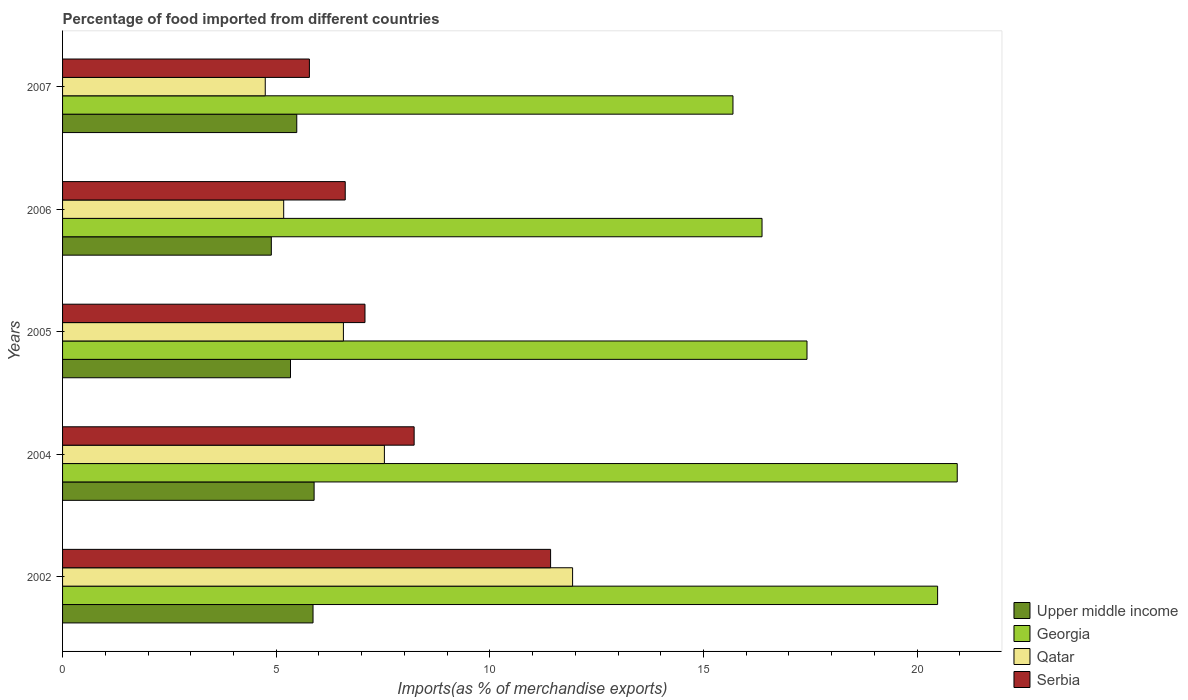Are the number of bars per tick equal to the number of legend labels?
Give a very brief answer. Yes. Are the number of bars on each tick of the Y-axis equal?
Make the answer very short. Yes. How many bars are there on the 2nd tick from the top?
Provide a short and direct response. 4. How many bars are there on the 3rd tick from the bottom?
Provide a succinct answer. 4. What is the label of the 5th group of bars from the top?
Keep it short and to the point. 2002. What is the percentage of imports to different countries in Qatar in 2007?
Offer a very short reply. 4.74. Across all years, what is the maximum percentage of imports to different countries in Qatar?
Keep it short and to the point. 11.94. Across all years, what is the minimum percentage of imports to different countries in Serbia?
Ensure brevity in your answer.  5.78. In which year was the percentage of imports to different countries in Qatar maximum?
Keep it short and to the point. 2002. In which year was the percentage of imports to different countries in Upper middle income minimum?
Make the answer very short. 2006. What is the total percentage of imports to different countries in Upper middle income in the graph?
Ensure brevity in your answer.  27.45. What is the difference between the percentage of imports to different countries in Upper middle income in 2006 and that in 2007?
Give a very brief answer. -0.6. What is the difference between the percentage of imports to different countries in Serbia in 2005 and the percentage of imports to different countries in Qatar in 2002?
Your answer should be compact. -4.86. What is the average percentage of imports to different countries in Qatar per year?
Your response must be concise. 7.19. In the year 2004, what is the difference between the percentage of imports to different countries in Upper middle income and percentage of imports to different countries in Georgia?
Make the answer very short. -15.05. What is the ratio of the percentage of imports to different countries in Serbia in 2004 to that in 2007?
Keep it short and to the point. 1.42. What is the difference between the highest and the second highest percentage of imports to different countries in Upper middle income?
Ensure brevity in your answer.  0.03. What is the difference between the highest and the lowest percentage of imports to different countries in Georgia?
Your response must be concise. 5.25. In how many years, is the percentage of imports to different countries in Georgia greater than the average percentage of imports to different countries in Georgia taken over all years?
Keep it short and to the point. 2. Is the sum of the percentage of imports to different countries in Upper middle income in 2002 and 2005 greater than the maximum percentage of imports to different countries in Qatar across all years?
Offer a very short reply. No. Is it the case that in every year, the sum of the percentage of imports to different countries in Serbia and percentage of imports to different countries in Upper middle income is greater than the sum of percentage of imports to different countries in Georgia and percentage of imports to different countries in Qatar?
Your answer should be compact. No. What does the 3rd bar from the top in 2006 represents?
Your response must be concise. Georgia. What does the 1st bar from the bottom in 2006 represents?
Provide a short and direct response. Upper middle income. Is it the case that in every year, the sum of the percentage of imports to different countries in Serbia and percentage of imports to different countries in Georgia is greater than the percentage of imports to different countries in Qatar?
Offer a very short reply. Yes. Are all the bars in the graph horizontal?
Provide a short and direct response. Yes. How many years are there in the graph?
Your answer should be compact. 5. What is the difference between two consecutive major ticks on the X-axis?
Provide a succinct answer. 5. Does the graph contain grids?
Make the answer very short. No. Where does the legend appear in the graph?
Make the answer very short. Bottom right. How are the legend labels stacked?
Keep it short and to the point. Vertical. What is the title of the graph?
Give a very brief answer. Percentage of food imported from different countries. What is the label or title of the X-axis?
Your answer should be very brief. Imports(as % of merchandise exports). What is the label or title of the Y-axis?
Ensure brevity in your answer.  Years. What is the Imports(as % of merchandise exports) of Upper middle income in 2002?
Ensure brevity in your answer.  5.86. What is the Imports(as % of merchandise exports) of Georgia in 2002?
Provide a succinct answer. 20.48. What is the Imports(as % of merchandise exports) in Qatar in 2002?
Give a very brief answer. 11.94. What is the Imports(as % of merchandise exports) of Serbia in 2002?
Your answer should be very brief. 11.42. What is the Imports(as % of merchandise exports) in Upper middle income in 2004?
Ensure brevity in your answer.  5.89. What is the Imports(as % of merchandise exports) of Georgia in 2004?
Offer a terse response. 20.94. What is the Imports(as % of merchandise exports) in Qatar in 2004?
Give a very brief answer. 7.53. What is the Imports(as % of merchandise exports) in Serbia in 2004?
Ensure brevity in your answer.  8.23. What is the Imports(as % of merchandise exports) of Upper middle income in 2005?
Give a very brief answer. 5.33. What is the Imports(as % of merchandise exports) of Georgia in 2005?
Provide a succinct answer. 17.42. What is the Imports(as % of merchandise exports) of Qatar in 2005?
Offer a terse response. 6.57. What is the Imports(as % of merchandise exports) of Serbia in 2005?
Offer a very short reply. 7.08. What is the Imports(as % of merchandise exports) of Upper middle income in 2006?
Your response must be concise. 4.89. What is the Imports(as % of merchandise exports) in Georgia in 2006?
Give a very brief answer. 16.37. What is the Imports(as % of merchandise exports) in Qatar in 2006?
Make the answer very short. 5.18. What is the Imports(as % of merchandise exports) in Serbia in 2006?
Make the answer very short. 6.62. What is the Imports(as % of merchandise exports) in Upper middle income in 2007?
Your response must be concise. 5.48. What is the Imports(as % of merchandise exports) of Georgia in 2007?
Keep it short and to the point. 15.69. What is the Imports(as % of merchandise exports) of Qatar in 2007?
Provide a short and direct response. 4.74. What is the Imports(as % of merchandise exports) in Serbia in 2007?
Give a very brief answer. 5.78. Across all years, what is the maximum Imports(as % of merchandise exports) in Upper middle income?
Ensure brevity in your answer.  5.89. Across all years, what is the maximum Imports(as % of merchandise exports) in Georgia?
Your answer should be very brief. 20.94. Across all years, what is the maximum Imports(as % of merchandise exports) in Qatar?
Give a very brief answer. 11.94. Across all years, what is the maximum Imports(as % of merchandise exports) of Serbia?
Your answer should be very brief. 11.42. Across all years, what is the minimum Imports(as % of merchandise exports) of Upper middle income?
Provide a succinct answer. 4.89. Across all years, what is the minimum Imports(as % of merchandise exports) in Georgia?
Your answer should be very brief. 15.69. Across all years, what is the minimum Imports(as % of merchandise exports) in Qatar?
Give a very brief answer. 4.74. Across all years, what is the minimum Imports(as % of merchandise exports) of Serbia?
Provide a succinct answer. 5.78. What is the total Imports(as % of merchandise exports) of Upper middle income in the graph?
Offer a very short reply. 27.45. What is the total Imports(as % of merchandise exports) of Georgia in the graph?
Your answer should be compact. 90.9. What is the total Imports(as % of merchandise exports) of Qatar in the graph?
Offer a terse response. 35.96. What is the total Imports(as % of merchandise exports) of Serbia in the graph?
Offer a terse response. 39.12. What is the difference between the Imports(as % of merchandise exports) of Upper middle income in 2002 and that in 2004?
Make the answer very short. -0.03. What is the difference between the Imports(as % of merchandise exports) of Georgia in 2002 and that in 2004?
Provide a succinct answer. -0.46. What is the difference between the Imports(as % of merchandise exports) in Qatar in 2002 and that in 2004?
Your response must be concise. 4.4. What is the difference between the Imports(as % of merchandise exports) of Serbia in 2002 and that in 2004?
Your answer should be very brief. 3.19. What is the difference between the Imports(as % of merchandise exports) in Upper middle income in 2002 and that in 2005?
Keep it short and to the point. 0.53. What is the difference between the Imports(as % of merchandise exports) of Georgia in 2002 and that in 2005?
Provide a short and direct response. 3.06. What is the difference between the Imports(as % of merchandise exports) of Qatar in 2002 and that in 2005?
Provide a short and direct response. 5.36. What is the difference between the Imports(as % of merchandise exports) of Serbia in 2002 and that in 2005?
Your answer should be very brief. 4.34. What is the difference between the Imports(as % of merchandise exports) in Upper middle income in 2002 and that in 2006?
Your answer should be very brief. 0.98. What is the difference between the Imports(as % of merchandise exports) of Georgia in 2002 and that in 2006?
Provide a succinct answer. 4.11. What is the difference between the Imports(as % of merchandise exports) in Qatar in 2002 and that in 2006?
Provide a succinct answer. 6.76. What is the difference between the Imports(as % of merchandise exports) in Serbia in 2002 and that in 2006?
Your response must be concise. 4.81. What is the difference between the Imports(as % of merchandise exports) in Upper middle income in 2002 and that in 2007?
Offer a terse response. 0.38. What is the difference between the Imports(as % of merchandise exports) in Georgia in 2002 and that in 2007?
Your response must be concise. 4.79. What is the difference between the Imports(as % of merchandise exports) of Qatar in 2002 and that in 2007?
Give a very brief answer. 7.19. What is the difference between the Imports(as % of merchandise exports) of Serbia in 2002 and that in 2007?
Give a very brief answer. 5.64. What is the difference between the Imports(as % of merchandise exports) of Upper middle income in 2004 and that in 2005?
Your answer should be very brief. 0.55. What is the difference between the Imports(as % of merchandise exports) of Georgia in 2004 and that in 2005?
Your answer should be compact. 3.52. What is the difference between the Imports(as % of merchandise exports) in Qatar in 2004 and that in 2005?
Your answer should be compact. 0.96. What is the difference between the Imports(as % of merchandise exports) of Serbia in 2004 and that in 2005?
Your answer should be compact. 1.15. What is the difference between the Imports(as % of merchandise exports) of Georgia in 2004 and that in 2006?
Ensure brevity in your answer.  4.57. What is the difference between the Imports(as % of merchandise exports) in Qatar in 2004 and that in 2006?
Offer a terse response. 2.36. What is the difference between the Imports(as % of merchandise exports) in Serbia in 2004 and that in 2006?
Your response must be concise. 1.61. What is the difference between the Imports(as % of merchandise exports) in Upper middle income in 2004 and that in 2007?
Offer a very short reply. 0.41. What is the difference between the Imports(as % of merchandise exports) of Georgia in 2004 and that in 2007?
Make the answer very short. 5.25. What is the difference between the Imports(as % of merchandise exports) in Qatar in 2004 and that in 2007?
Your answer should be compact. 2.79. What is the difference between the Imports(as % of merchandise exports) of Serbia in 2004 and that in 2007?
Provide a short and direct response. 2.45. What is the difference between the Imports(as % of merchandise exports) in Upper middle income in 2005 and that in 2006?
Make the answer very short. 0.45. What is the difference between the Imports(as % of merchandise exports) of Georgia in 2005 and that in 2006?
Provide a short and direct response. 1.05. What is the difference between the Imports(as % of merchandise exports) of Qatar in 2005 and that in 2006?
Your answer should be very brief. 1.4. What is the difference between the Imports(as % of merchandise exports) in Serbia in 2005 and that in 2006?
Your response must be concise. 0.46. What is the difference between the Imports(as % of merchandise exports) of Upper middle income in 2005 and that in 2007?
Provide a short and direct response. -0.15. What is the difference between the Imports(as % of merchandise exports) of Georgia in 2005 and that in 2007?
Your answer should be compact. 1.73. What is the difference between the Imports(as % of merchandise exports) in Qatar in 2005 and that in 2007?
Provide a short and direct response. 1.83. What is the difference between the Imports(as % of merchandise exports) of Serbia in 2005 and that in 2007?
Keep it short and to the point. 1.3. What is the difference between the Imports(as % of merchandise exports) of Upper middle income in 2006 and that in 2007?
Provide a succinct answer. -0.6. What is the difference between the Imports(as % of merchandise exports) of Georgia in 2006 and that in 2007?
Provide a short and direct response. 0.68. What is the difference between the Imports(as % of merchandise exports) in Qatar in 2006 and that in 2007?
Provide a succinct answer. 0.43. What is the difference between the Imports(as % of merchandise exports) in Serbia in 2006 and that in 2007?
Keep it short and to the point. 0.84. What is the difference between the Imports(as % of merchandise exports) of Upper middle income in 2002 and the Imports(as % of merchandise exports) of Georgia in 2004?
Your answer should be very brief. -15.08. What is the difference between the Imports(as % of merchandise exports) in Upper middle income in 2002 and the Imports(as % of merchandise exports) in Qatar in 2004?
Your answer should be compact. -1.67. What is the difference between the Imports(as % of merchandise exports) in Upper middle income in 2002 and the Imports(as % of merchandise exports) in Serbia in 2004?
Offer a terse response. -2.37. What is the difference between the Imports(as % of merchandise exports) in Georgia in 2002 and the Imports(as % of merchandise exports) in Qatar in 2004?
Your answer should be very brief. 12.95. What is the difference between the Imports(as % of merchandise exports) in Georgia in 2002 and the Imports(as % of merchandise exports) in Serbia in 2004?
Ensure brevity in your answer.  12.25. What is the difference between the Imports(as % of merchandise exports) in Qatar in 2002 and the Imports(as % of merchandise exports) in Serbia in 2004?
Provide a succinct answer. 3.71. What is the difference between the Imports(as % of merchandise exports) of Upper middle income in 2002 and the Imports(as % of merchandise exports) of Georgia in 2005?
Your answer should be very brief. -11.56. What is the difference between the Imports(as % of merchandise exports) in Upper middle income in 2002 and the Imports(as % of merchandise exports) in Qatar in 2005?
Make the answer very short. -0.71. What is the difference between the Imports(as % of merchandise exports) in Upper middle income in 2002 and the Imports(as % of merchandise exports) in Serbia in 2005?
Your answer should be compact. -1.22. What is the difference between the Imports(as % of merchandise exports) in Georgia in 2002 and the Imports(as % of merchandise exports) in Qatar in 2005?
Make the answer very short. 13.91. What is the difference between the Imports(as % of merchandise exports) in Georgia in 2002 and the Imports(as % of merchandise exports) in Serbia in 2005?
Your response must be concise. 13.4. What is the difference between the Imports(as % of merchandise exports) in Qatar in 2002 and the Imports(as % of merchandise exports) in Serbia in 2005?
Make the answer very short. 4.86. What is the difference between the Imports(as % of merchandise exports) in Upper middle income in 2002 and the Imports(as % of merchandise exports) in Georgia in 2006?
Give a very brief answer. -10.51. What is the difference between the Imports(as % of merchandise exports) of Upper middle income in 2002 and the Imports(as % of merchandise exports) of Qatar in 2006?
Provide a succinct answer. 0.69. What is the difference between the Imports(as % of merchandise exports) of Upper middle income in 2002 and the Imports(as % of merchandise exports) of Serbia in 2006?
Provide a succinct answer. -0.75. What is the difference between the Imports(as % of merchandise exports) in Georgia in 2002 and the Imports(as % of merchandise exports) in Qatar in 2006?
Your answer should be compact. 15.3. What is the difference between the Imports(as % of merchandise exports) in Georgia in 2002 and the Imports(as % of merchandise exports) in Serbia in 2006?
Your answer should be compact. 13.86. What is the difference between the Imports(as % of merchandise exports) in Qatar in 2002 and the Imports(as % of merchandise exports) in Serbia in 2006?
Your answer should be compact. 5.32. What is the difference between the Imports(as % of merchandise exports) of Upper middle income in 2002 and the Imports(as % of merchandise exports) of Georgia in 2007?
Ensure brevity in your answer.  -9.83. What is the difference between the Imports(as % of merchandise exports) of Upper middle income in 2002 and the Imports(as % of merchandise exports) of Qatar in 2007?
Your answer should be compact. 1.12. What is the difference between the Imports(as % of merchandise exports) in Upper middle income in 2002 and the Imports(as % of merchandise exports) in Serbia in 2007?
Make the answer very short. 0.08. What is the difference between the Imports(as % of merchandise exports) in Georgia in 2002 and the Imports(as % of merchandise exports) in Qatar in 2007?
Your response must be concise. 15.74. What is the difference between the Imports(as % of merchandise exports) of Georgia in 2002 and the Imports(as % of merchandise exports) of Serbia in 2007?
Your response must be concise. 14.7. What is the difference between the Imports(as % of merchandise exports) of Qatar in 2002 and the Imports(as % of merchandise exports) of Serbia in 2007?
Make the answer very short. 6.16. What is the difference between the Imports(as % of merchandise exports) in Upper middle income in 2004 and the Imports(as % of merchandise exports) in Georgia in 2005?
Keep it short and to the point. -11.54. What is the difference between the Imports(as % of merchandise exports) in Upper middle income in 2004 and the Imports(as % of merchandise exports) in Qatar in 2005?
Keep it short and to the point. -0.69. What is the difference between the Imports(as % of merchandise exports) in Upper middle income in 2004 and the Imports(as % of merchandise exports) in Serbia in 2005?
Provide a short and direct response. -1.19. What is the difference between the Imports(as % of merchandise exports) of Georgia in 2004 and the Imports(as % of merchandise exports) of Qatar in 2005?
Offer a terse response. 14.37. What is the difference between the Imports(as % of merchandise exports) in Georgia in 2004 and the Imports(as % of merchandise exports) in Serbia in 2005?
Your answer should be very brief. 13.86. What is the difference between the Imports(as % of merchandise exports) of Qatar in 2004 and the Imports(as % of merchandise exports) of Serbia in 2005?
Provide a short and direct response. 0.45. What is the difference between the Imports(as % of merchandise exports) of Upper middle income in 2004 and the Imports(as % of merchandise exports) of Georgia in 2006?
Your answer should be compact. -10.48. What is the difference between the Imports(as % of merchandise exports) in Upper middle income in 2004 and the Imports(as % of merchandise exports) in Qatar in 2006?
Offer a very short reply. 0.71. What is the difference between the Imports(as % of merchandise exports) in Upper middle income in 2004 and the Imports(as % of merchandise exports) in Serbia in 2006?
Provide a succinct answer. -0.73. What is the difference between the Imports(as % of merchandise exports) in Georgia in 2004 and the Imports(as % of merchandise exports) in Qatar in 2006?
Provide a short and direct response. 15.76. What is the difference between the Imports(as % of merchandise exports) of Georgia in 2004 and the Imports(as % of merchandise exports) of Serbia in 2006?
Your answer should be very brief. 14.32. What is the difference between the Imports(as % of merchandise exports) of Upper middle income in 2004 and the Imports(as % of merchandise exports) of Georgia in 2007?
Keep it short and to the point. -9.8. What is the difference between the Imports(as % of merchandise exports) in Upper middle income in 2004 and the Imports(as % of merchandise exports) in Qatar in 2007?
Ensure brevity in your answer.  1.14. What is the difference between the Imports(as % of merchandise exports) in Upper middle income in 2004 and the Imports(as % of merchandise exports) in Serbia in 2007?
Your answer should be compact. 0.11. What is the difference between the Imports(as % of merchandise exports) of Georgia in 2004 and the Imports(as % of merchandise exports) of Qatar in 2007?
Your answer should be compact. 16.2. What is the difference between the Imports(as % of merchandise exports) of Georgia in 2004 and the Imports(as % of merchandise exports) of Serbia in 2007?
Your answer should be compact. 15.16. What is the difference between the Imports(as % of merchandise exports) in Qatar in 2004 and the Imports(as % of merchandise exports) in Serbia in 2007?
Provide a short and direct response. 1.76. What is the difference between the Imports(as % of merchandise exports) in Upper middle income in 2005 and the Imports(as % of merchandise exports) in Georgia in 2006?
Make the answer very short. -11.04. What is the difference between the Imports(as % of merchandise exports) of Upper middle income in 2005 and the Imports(as % of merchandise exports) of Qatar in 2006?
Your answer should be compact. 0.16. What is the difference between the Imports(as % of merchandise exports) of Upper middle income in 2005 and the Imports(as % of merchandise exports) of Serbia in 2006?
Keep it short and to the point. -1.28. What is the difference between the Imports(as % of merchandise exports) in Georgia in 2005 and the Imports(as % of merchandise exports) in Qatar in 2006?
Offer a very short reply. 12.25. What is the difference between the Imports(as % of merchandise exports) of Georgia in 2005 and the Imports(as % of merchandise exports) of Serbia in 2006?
Provide a succinct answer. 10.81. What is the difference between the Imports(as % of merchandise exports) of Qatar in 2005 and the Imports(as % of merchandise exports) of Serbia in 2006?
Your response must be concise. -0.04. What is the difference between the Imports(as % of merchandise exports) in Upper middle income in 2005 and the Imports(as % of merchandise exports) in Georgia in 2007?
Offer a terse response. -10.36. What is the difference between the Imports(as % of merchandise exports) in Upper middle income in 2005 and the Imports(as % of merchandise exports) in Qatar in 2007?
Your response must be concise. 0.59. What is the difference between the Imports(as % of merchandise exports) of Upper middle income in 2005 and the Imports(as % of merchandise exports) of Serbia in 2007?
Ensure brevity in your answer.  -0.44. What is the difference between the Imports(as % of merchandise exports) of Georgia in 2005 and the Imports(as % of merchandise exports) of Qatar in 2007?
Give a very brief answer. 12.68. What is the difference between the Imports(as % of merchandise exports) of Georgia in 2005 and the Imports(as % of merchandise exports) of Serbia in 2007?
Keep it short and to the point. 11.65. What is the difference between the Imports(as % of merchandise exports) in Qatar in 2005 and the Imports(as % of merchandise exports) in Serbia in 2007?
Offer a very short reply. 0.8. What is the difference between the Imports(as % of merchandise exports) of Upper middle income in 2006 and the Imports(as % of merchandise exports) of Georgia in 2007?
Offer a terse response. -10.8. What is the difference between the Imports(as % of merchandise exports) of Upper middle income in 2006 and the Imports(as % of merchandise exports) of Qatar in 2007?
Your response must be concise. 0.14. What is the difference between the Imports(as % of merchandise exports) in Upper middle income in 2006 and the Imports(as % of merchandise exports) in Serbia in 2007?
Make the answer very short. -0.89. What is the difference between the Imports(as % of merchandise exports) in Georgia in 2006 and the Imports(as % of merchandise exports) in Qatar in 2007?
Your answer should be compact. 11.63. What is the difference between the Imports(as % of merchandise exports) of Georgia in 2006 and the Imports(as % of merchandise exports) of Serbia in 2007?
Make the answer very short. 10.59. What is the difference between the Imports(as % of merchandise exports) of Qatar in 2006 and the Imports(as % of merchandise exports) of Serbia in 2007?
Make the answer very short. -0.6. What is the average Imports(as % of merchandise exports) in Upper middle income per year?
Offer a very short reply. 5.49. What is the average Imports(as % of merchandise exports) of Georgia per year?
Ensure brevity in your answer.  18.18. What is the average Imports(as % of merchandise exports) of Qatar per year?
Offer a very short reply. 7.19. What is the average Imports(as % of merchandise exports) of Serbia per year?
Provide a succinct answer. 7.82. In the year 2002, what is the difference between the Imports(as % of merchandise exports) in Upper middle income and Imports(as % of merchandise exports) in Georgia?
Ensure brevity in your answer.  -14.62. In the year 2002, what is the difference between the Imports(as % of merchandise exports) in Upper middle income and Imports(as % of merchandise exports) in Qatar?
Your response must be concise. -6.07. In the year 2002, what is the difference between the Imports(as % of merchandise exports) in Upper middle income and Imports(as % of merchandise exports) in Serbia?
Offer a terse response. -5.56. In the year 2002, what is the difference between the Imports(as % of merchandise exports) of Georgia and Imports(as % of merchandise exports) of Qatar?
Provide a short and direct response. 8.54. In the year 2002, what is the difference between the Imports(as % of merchandise exports) in Georgia and Imports(as % of merchandise exports) in Serbia?
Make the answer very short. 9.06. In the year 2002, what is the difference between the Imports(as % of merchandise exports) in Qatar and Imports(as % of merchandise exports) in Serbia?
Your response must be concise. 0.51. In the year 2004, what is the difference between the Imports(as % of merchandise exports) of Upper middle income and Imports(as % of merchandise exports) of Georgia?
Offer a very short reply. -15.05. In the year 2004, what is the difference between the Imports(as % of merchandise exports) in Upper middle income and Imports(as % of merchandise exports) in Qatar?
Your answer should be compact. -1.65. In the year 2004, what is the difference between the Imports(as % of merchandise exports) in Upper middle income and Imports(as % of merchandise exports) in Serbia?
Your answer should be very brief. -2.34. In the year 2004, what is the difference between the Imports(as % of merchandise exports) of Georgia and Imports(as % of merchandise exports) of Qatar?
Your response must be concise. 13.41. In the year 2004, what is the difference between the Imports(as % of merchandise exports) of Georgia and Imports(as % of merchandise exports) of Serbia?
Ensure brevity in your answer.  12.71. In the year 2004, what is the difference between the Imports(as % of merchandise exports) of Qatar and Imports(as % of merchandise exports) of Serbia?
Your response must be concise. -0.7. In the year 2005, what is the difference between the Imports(as % of merchandise exports) in Upper middle income and Imports(as % of merchandise exports) in Georgia?
Offer a very short reply. -12.09. In the year 2005, what is the difference between the Imports(as % of merchandise exports) in Upper middle income and Imports(as % of merchandise exports) in Qatar?
Provide a short and direct response. -1.24. In the year 2005, what is the difference between the Imports(as % of merchandise exports) in Upper middle income and Imports(as % of merchandise exports) in Serbia?
Provide a short and direct response. -1.74. In the year 2005, what is the difference between the Imports(as % of merchandise exports) of Georgia and Imports(as % of merchandise exports) of Qatar?
Make the answer very short. 10.85. In the year 2005, what is the difference between the Imports(as % of merchandise exports) of Georgia and Imports(as % of merchandise exports) of Serbia?
Provide a short and direct response. 10.35. In the year 2005, what is the difference between the Imports(as % of merchandise exports) in Qatar and Imports(as % of merchandise exports) in Serbia?
Your answer should be very brief. -0.51. In the year 2006, what is the difference between the Imports(as % of merchandise exports) in Upper middle income and Imports(as % of merchandise exports) in Georgia?
Your response must be concise. -11.48. In the year 2006, what is the difference between the Imports(as % of merchandise exports) in Upper middle income and Imports(as % of merchandise exports) in Qatar?
Your answer should be compact. -0.29. In the year 2006, what is the difference between the Imports(as % of merchandise exports) in Upper middle income and Imports(as % of merchandise exports) in Serbia?
Make the answer very short. -1.73. In the year 2006, what is the difference between the Imports(as % of merchandise exports) in Georgia and Imports(as % of merchandise exports) in Qatar?
Your answer should be very brief. 11.2. In the year 2006, what is the difference between the Imports(as % of merchandise exports) in Georgia and Imports(as % of merchandise exports) in Serbia?
Your answer should be very brief. 9.75. In the year 2006, what is the difference between the Imports(as % of merchandise exports) in Qatar and Imports(as % of merchandise exports) in Serbia?
Your answer should be compact. -1.44. In the year 2007, what is the difference between the Imports(as % of merchandise exports) in Upper middle income and Imports(as % of merchandise exports) in Georgia?
Your response must be concise. -10.21. In the year 2007, what is the difference between the Imports(as % of merchandise exports) in Upper middle income and Imports(as % of merchandise exports) in Qatar?
Keep it short and to the point. 0.74. In the year 2007, what is the difference between the Imports(as % of merchandise exports) of Upper middle income and Imports(as % of merchandise exports) of Serbia?
Your answer should be compact. -0.3. In the year 2007, what is the difference between the Imports(as % of merchandise exports) of Georgia and Imports(as % of merchandise exports) of Qatar?
Provide a short and direct response. 10.95. In the year 2007, what is the difference between the Imports(as % of merchandise exports) in Georgia and Imports(as % of merchandise exports) in Serbia?
Give a very brief answer. 9.91. In the year 2007, what is the difference between the Imports(as % of merchandise exports) in Qatar and Imports(as % of merchandise exports) in Serbia?
Make the answer very short. -1.03. What is the ratio of the Imports(as % of merchandise exports) of Upper middle income in 2002 to that in 2004?
Your answer should be compact. 1. What is the ratio of the Imports(as % of merchandise exports) of Georgia in 2002 to that in 2004?
Give a very brief answer. 0.98. What is the ratio of the Imports(as % of merchandise exports) of Qatar in 2002 to that in 2004?
Make the answer very short. 1.58. What is the ratio of the Imports(as % of merchandise exports) of Serbia in 2002 to that in 2004?
Provide a short and direct response. 1.39. What is the ratio of the Imports(as % of merchandise exports) of Upper middle income in 2002 to that in 2005?
Offer a terse response. 1.1. What is the ratio of the Imports(as % of merchandise exports) in Georgia in 2002 to that in 2005?
Provide a succinct answer. 1.18. What is the ratio of the Imports(as % of merchandise exports) in Qatar in 2002 to that in 2005?
Ensure brevity in your answer.  1.82. What is the ratio of the Imports(as % of merchandise exports) of Serbia in 2002 to that in 2005?
Your response must be concise. 1.61. What is the ratio of the Imports(as % of merchandise exports) of Upper middle income in 2002 to that in 2006?
Ensure brevity in your answer.  1.2. What is the ratio of the Imports(as % of merchandise exports) of Georgia in 2002 to that in 2006?
Give a very brief answer. 1.25. What is the ratio of the Imports(as % of merchandise exports) of Qatar in 2002 to that in 2006?
Provide a succinct answer. 2.31. What is the ratio of the Imports(as % of merchandise exports) of Serbia in 2002 to that in 2006?
Provide a short and direct response. 1.73. What is the ratio of the Imports(as % of merchandise exports) in Upper middle income in 2002 to that in 2007?
Your response must be concise. 1.07. What is the ratio of the Imports(as % of merchandise exports) of Georgia in 2002 to that in 2007?
Your response must be concise. 1.31. What is the ratio of the Imports(as % of merchandise exports) in Qatar in 2002 to that in 2007?
Offer a terse response. 2.52. What is the ratio of the Imports(as % of merchandise exports) of Serbia in 2002 to that in 2007?
Provide a succinct answer. 1.98. What is the ratio of the Imports(as % of merchandise exports) in Upper middle income in 2004 to that in 2005?
Your response must be concise. 1.1. What is the ratio of the Imports(as % of merchandise exports) of Georgia in 2004 to that in 2005?
Offer a terse response. 1.2. What is the ratio of the Imports(as % of merchandise exports) of Qatar in 2004 to that in 2005?
Your answer should be very brief. 1.15. What is the ratio of the Imports(as % of merchandise exports) in Serbia in 2004 to that in 2005?
Give a very brief answer. 1.16. What is the ratio of the Imports(as % of merchandise exports) of Upper middle income in 2004 to that in 2006?
Offer a terse response. 1.2. What is the ratio of the Imports(as % of merchandise exports) in Georgia in 2004 to that in 2006?
Provide a succinct answer. 1.28. What is the ratio of the Imports(as % of merchandise exports) in Qatar in 2004 to that in 2006?
Your answer should be very brief. 1.46. What is the ratio of the Imports(as % of merchandise exports) in Serbia in 2004 to that in 2006?
Make the answer very short. 1.24. What is the ratio of the Imports(as % of merchandise exports) in Upper middle income in 2004 to that in 2007?
Your answer should be very brief. 1.07. What is the ratio of the Imports(as % of merchandise exports) of Georgia in 2004 to that in 2007?
Offer a very short reply. 1.33. What is the ratio of the Imports(as % of merchandise exports) in Qatar in 2004 to that in 2007?
Your answer should be very brief. 1.59. What is the ratio of the Imports(as % of merchandise exports) in Serbia in 2004 to that in 2007?
Provide a short and direct response. 1.42. What is the ratio of the Imports(as % of merchandise exports) of Upper middle income in 2005 to that in 2006?
Your answer should be compact. 1.09. What is the ratio of the Imports(as % of merchandise exports) of Georgia in 2005 to that in 2006?
Provide a short and direct response. 1.06. What is the ratio of the Imports(as % of merchandise exports) of Qatar in 2005 to that in 2006?
Give a very brief answer. 1.27. What is the ratio of the Imports(as % of merchandise exports) in Serbia in 2005 to that in 2006?
Offer a very short reply. 1.07. What is the ratio of the Imports(as % of merchandise exports) in Upper middle income in 2005 to that in 2007?
Your answer should be compact. 0.97. What is the ratio of the Imports(as % of merchandise exports) of Georgia in 2005 to that in 2007?
Your response must be concise. 1.11. What is the ratio of the Imports(as % of merchandise exports) in Qatar in 2005 to that in 2007?
Your answer should be compact. 1.39. What is the ratio of the Imports(as % of merchandise exports) in Serbia in 2005 to that in 2007?
Offer a terse response. 1.23. What is the ratio of the Imports(as % of merchandise exports) of Upper middle income in 2006 to that in 2007?
Provide a succinct answer. 0.89. What is the ratio of the Imports(as % of merchandise exports) of Georgia in 2006 to that in 2007?
Keep it short and to the point. 1.04. What is the ratio of the Imports(as % of merchandise exports) in Serbia in 2006 to that in 2007?
Ensure brevity in your answer.  1.15. What is the difference between the highest and the second highest Imports(as % of merchandise exports) of Upper middle income?
Keep it short and to the point. 0.03. What is the difference between the highest and the second highest Imports(as % of merchandise exports) of Georgia?
Your answer should be very brief. 0.46. What is the difference between the highest and the second highest Imports(as % of merchandise exports) in Qatar?
Your answer should be compact. 4.4. What is the difference between the highest and the second highest Imports(as % of merchandise exports) of Serbia?
Provide a short and direct response. 3.19. What is the difference between the highest and the lowest Imports(as % of merchandise exports) in Upper middle income?
Your answer should be compact. 1. What is the difference between the highest and the lowest Imports(as % of merchandise exports) in Georgia?
Provide a succinct answer. 5.25. What is the difference between the highest and the lowest Imports(as % of merchandise exports) in Qatar?
Your answer should be compact. 7.19. What is the difference between the highest and the lowest Imports(as % of merchandise exports) in Serbia?
Offer a terse response. 5.64. 